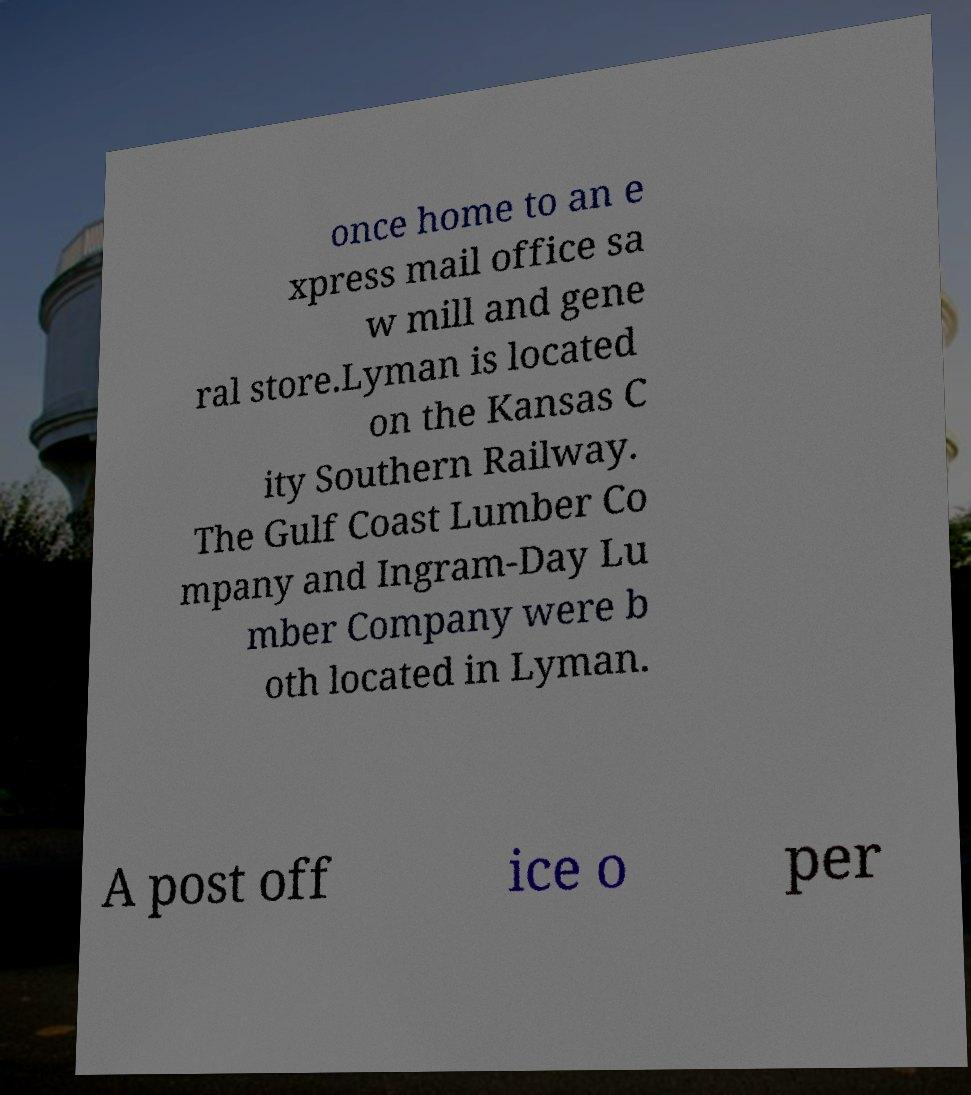Please read and relay the text visible in this image. What does it say? once home to an e xpress mail office sa w mill and gene ral store.Lyman is located on the Kansas C ity Southern Railway. The Gulf Coast Lumber Co mpany and Ingram-Day Lu mber Company were b oth located in Lyman. A post off ice o per 